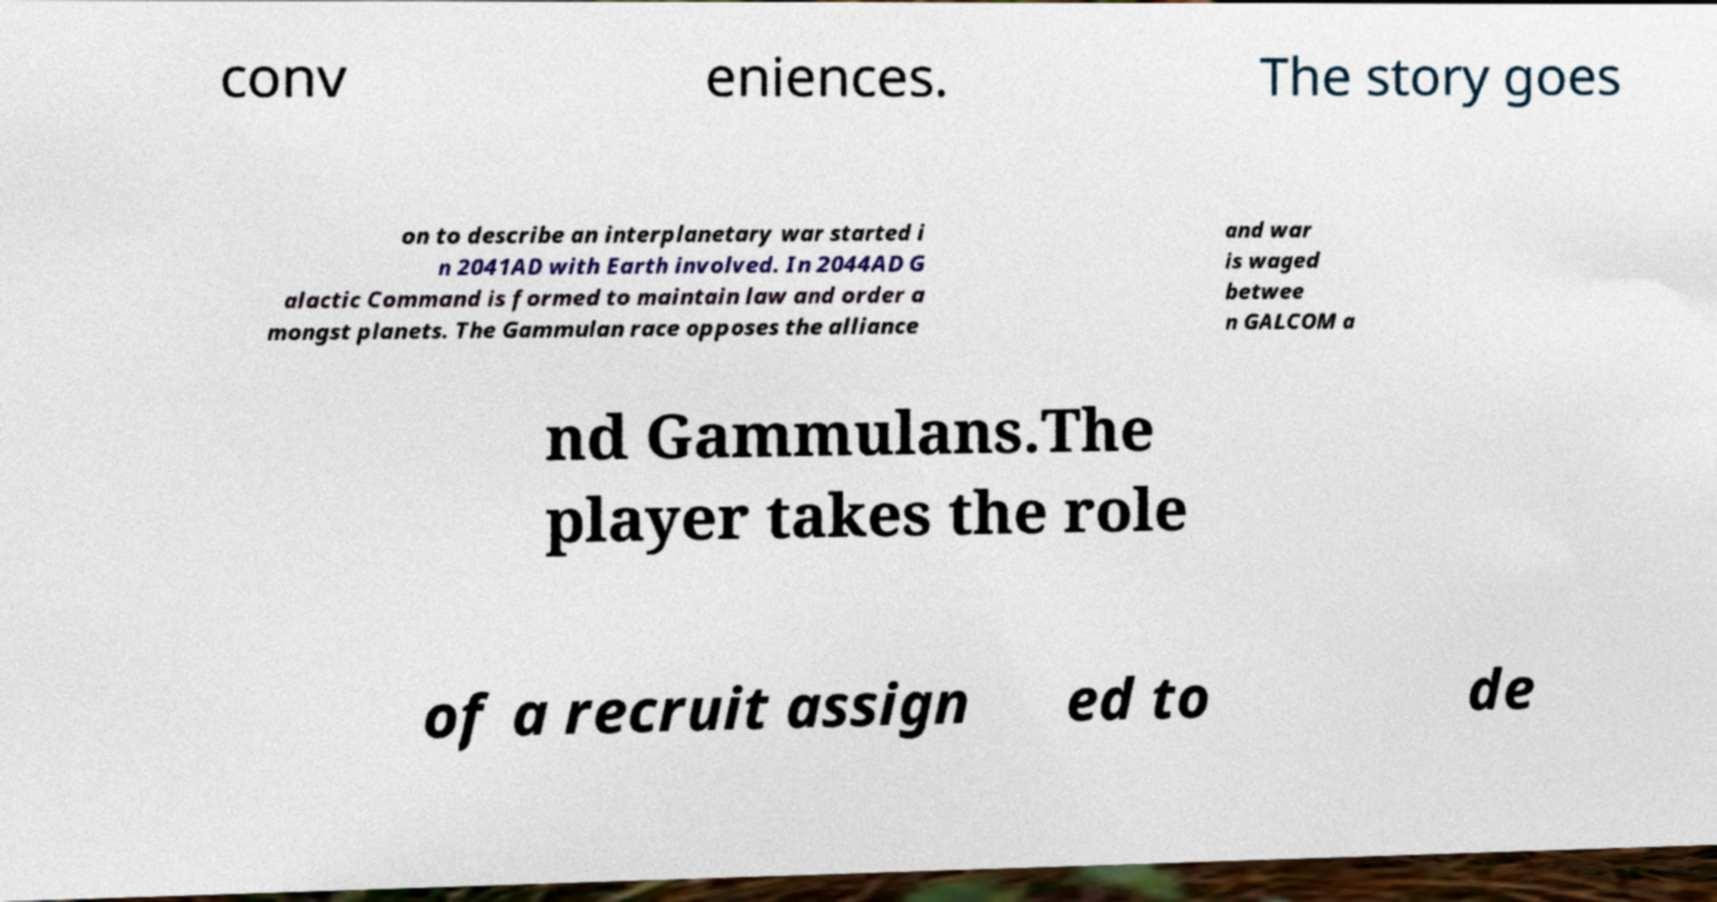Could you assist in decoding the text presented in this image and type it out clearly? conv eniences. The story goes on to describe an interplanetary war started i n 2041AD with Earth involved. In 2044AD G alactic Command is formed to maintain law and order a mongst planets. The Gammulan race opposes the alliance and war is waged betwee n GALCOM a nd Gammulans.The player takes the role of a recruit assign ed to de 